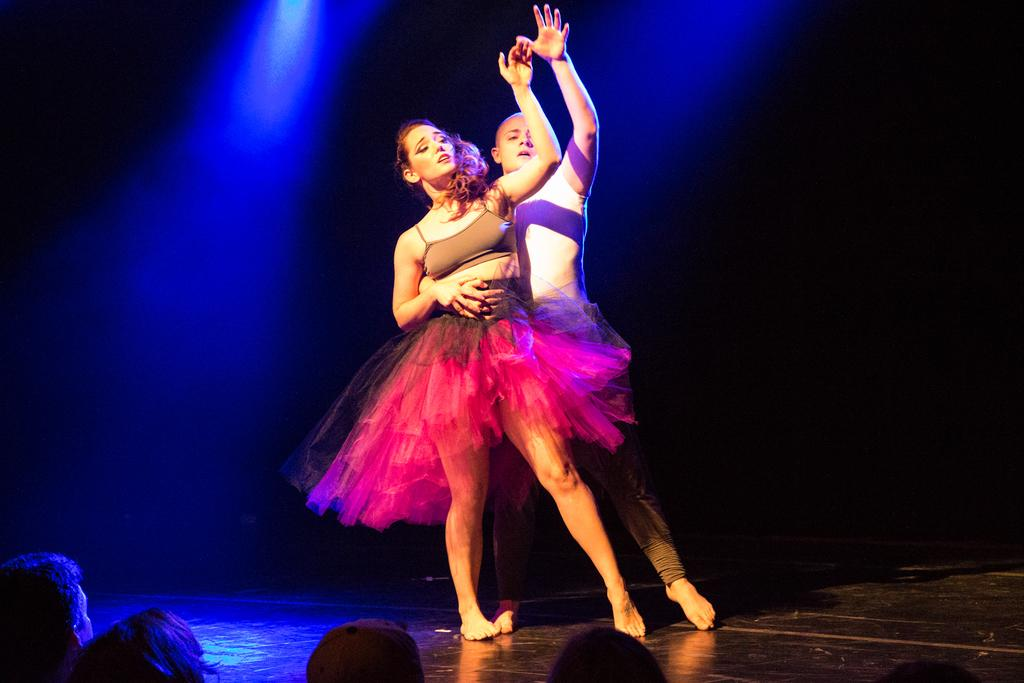Who are the two people in the image? There is a man and a woman in the image. What are the man and woman doing in the image? The man and woman are dancing on the floor. How is the man interacting with the woman while dancing? The man is holding the woman with his hand. Are there any other people present in the image? Yes, there are people watching the dancing couple. What type of hen is present in the image? There is no hen present in the image. 